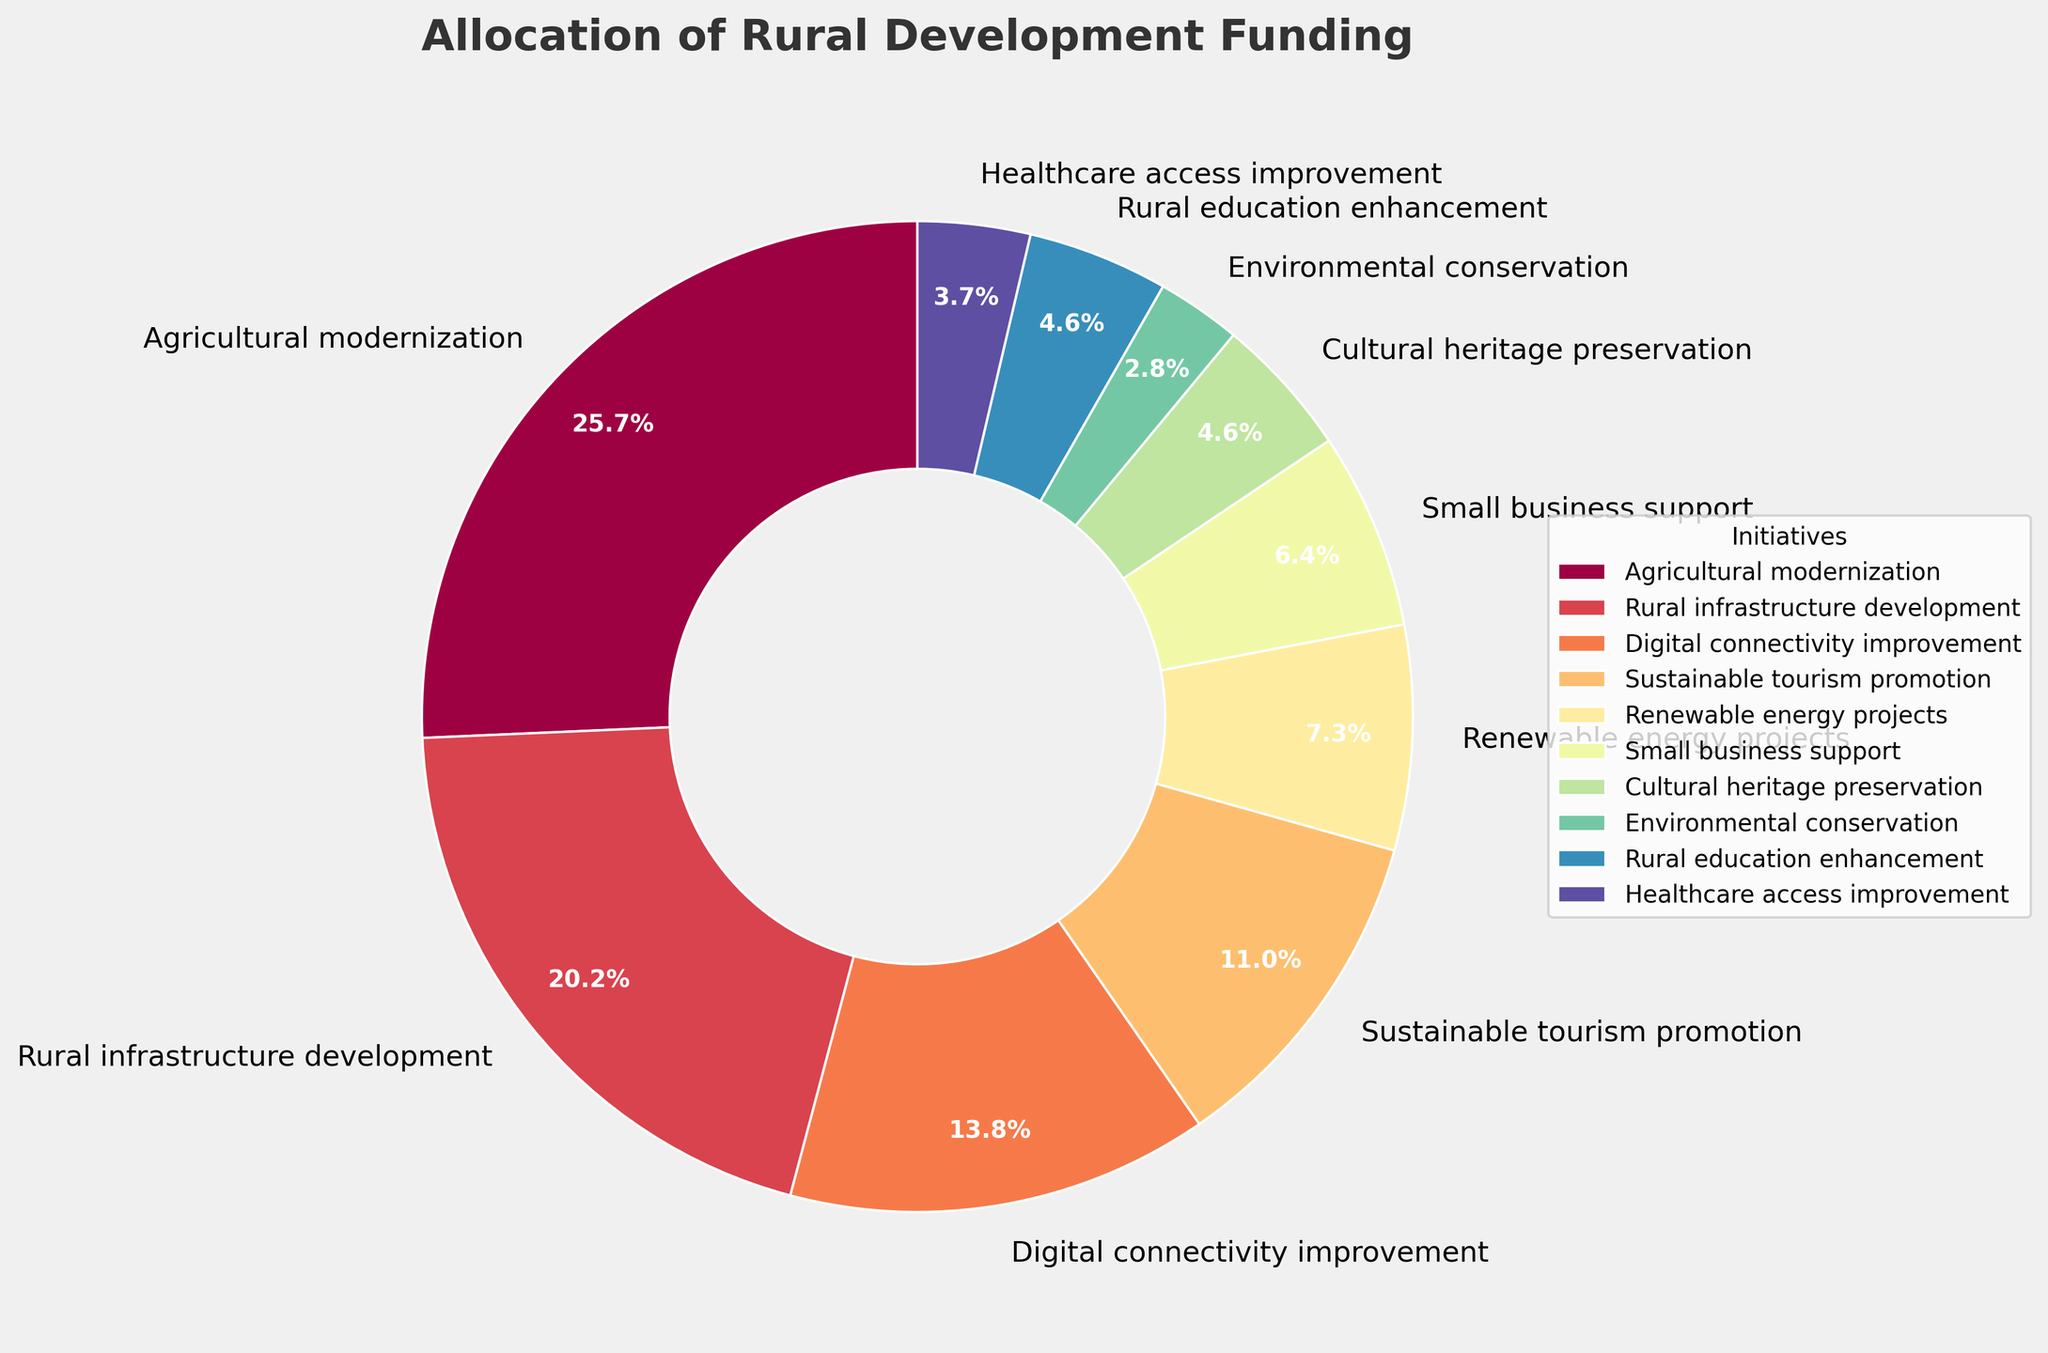**Compositional questions**
1. What's the combined percentage of funds allocated to Agricultural Modernization and Rural Infrastructure Development? The percentages for Agricultural Modernization and Rural Infrastructure Development are 28% and 22%, respectively. Adding these together, 28 + 22 = 50.
Answer: 50% 2. What is the difference between the percentage of funds allocated to Agricultural Modernization and the smallest initiative? The percentage for Agricultural Modernization is 28% and the smallest initiative, Environmental Conservation, receives 3%. The difference is 28 - 3 = 25.
Answer: 25% 3. What's the average percentage for the initiatives receiving less than 10% of the total funding? The initiatives receiving less than 10% are Renewable Energy Projects (8%), Small Business Support (7%), Cultural Heritage Preservation (5%), Environmental Conservation (3%), Rural Education Enhancement (5%), and Healthcare Access Improvement (4%). The average is (8 + 7 + 5 + 3 + 5 + 4) / 6 = 32 / 6 ≈ 5.33.
Answer: 5.33% 4. What's the median percentage of the total funding allocations? The percentages are: 28, 22, 15, 12, 8, 7, 5, 5, 4, 3. The median of these sorted values is the average of the two middle numbers: (8 + 7) / 2 = 7.5.
Answer: 7.5% **Comparison questions**
5. Which initiative received the highest percentage of funding? The highest percentage funding is 28%, which is allocated to Agricultural Modernization.
Answer: Agricultural Modernization 6. Does Rural Infrastructure Development receive more funding than Digital Connectivity Improvement? Yes, Rural Infrastructure Development receives 22% and Digital Connectivity Improvement receives 15%. Comparing 22 > 15 confirms this.
Answer: Yes 7. Which initiatives receive equal percentages of funding? Cultural Heritage Preservation and Rural Education Enhancement both receive 5%.
Answer: Cultural Heritage Preservation and Rural Education Enhancement **Visual questions**
8. Which initiative is represented with the second largest wedge in the pie chart? The second largest wedge, visually, represents Rural Infrastructure Development, which receives 22%.
Answer: Rural Infrastructure Development 9. What color is associated with Environmental Conservation in the pie chart? Observing the color scheme in the pie chart, Environmental Conservation has a visually identifiable portion that corresponds to its label at 3%.
Answer: [The actual color description would be based on the specific visualization shown] 10. How is the percentage of Healthcare Access Improvement visually depicted in relation to the pie chart’s overall layout? Healthcare Access Improvement holds a 4% wedge in the pie chart, positioned with smaller wedge areas as seen in the lower portion of the chart.
Answer: Smaller wedge at 4% 